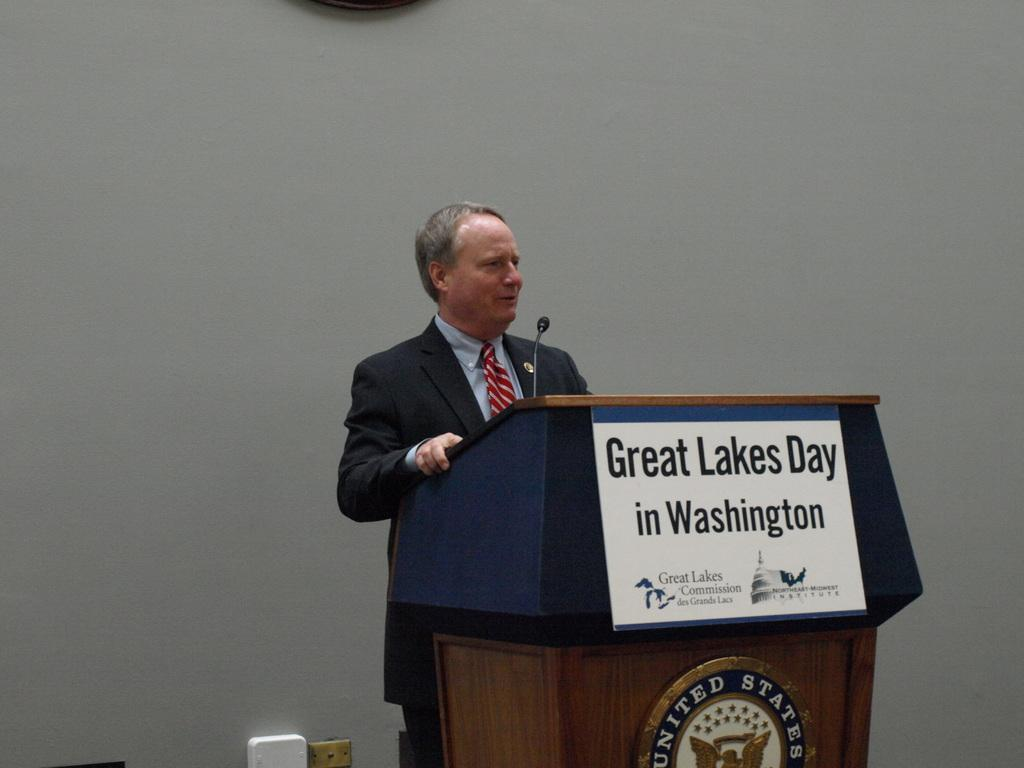<image>
Present a compact description of the photo's key features. a Great Lakes Day sign that is on the podium 